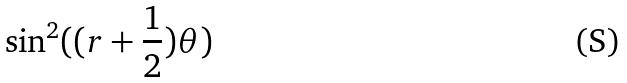Convert formula to latex. <formula><loc_0><loc_0><loc_500><loc_500>\sin ^ { 2 } ( ( r + \frac { 1 } { 2 } ) \theta )</formula> 